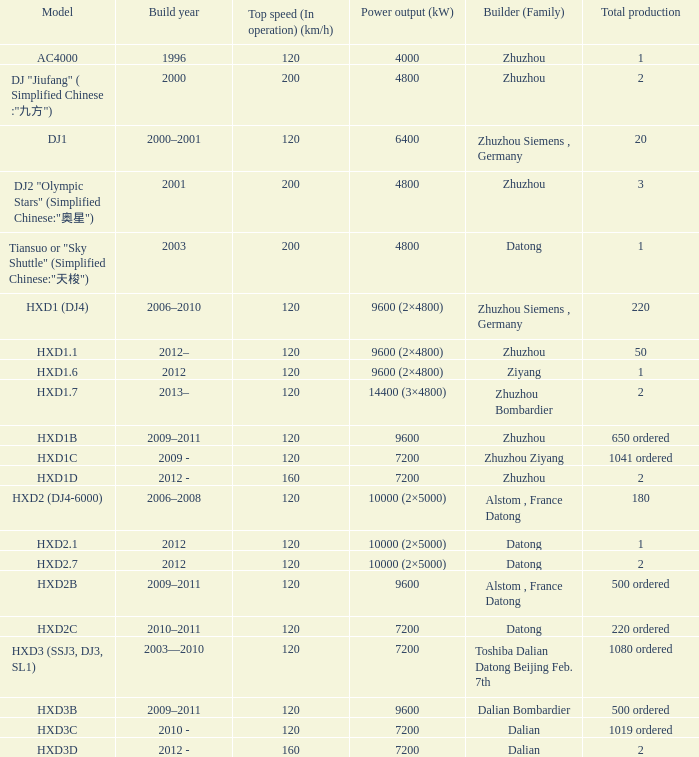What is the model with a zhuzhou builder and a 9600 kw power output? HXD1B. 